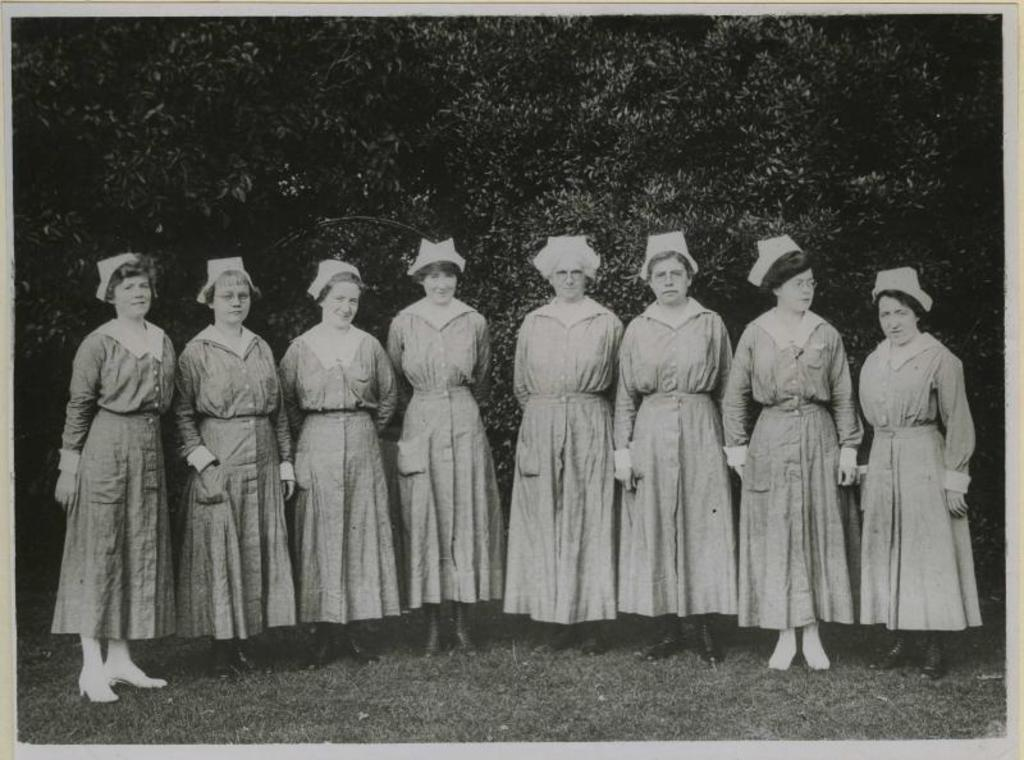What is the setting of the image? The people are standing on grass in the image. What is the gender of the individuals in the image? The people in the image are women. What is the facial expression of the women? The women are smiling. What can be seen in the background of the image? There are trees in the background of the image. What channel are the women watching in the image? There is no television or channel present in the image; it features women standing on grass. What type of thought can be seen floating above the women's heads in the image? There are no thoughts or thought bubbles present in the image. 